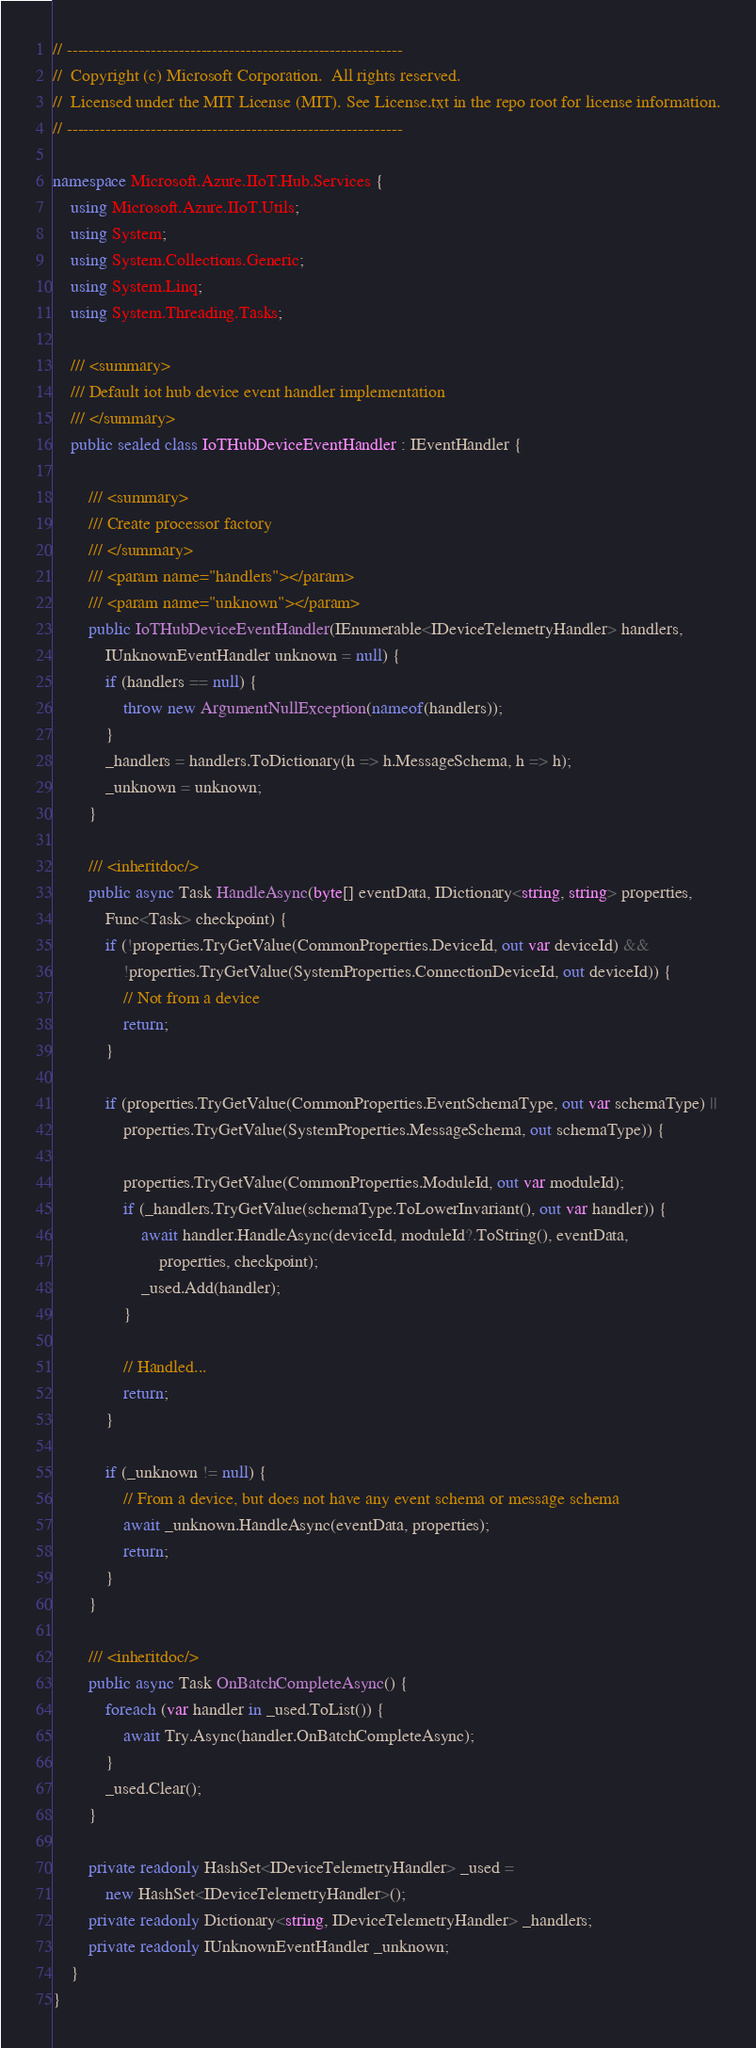<code> <loc_0><loc_0><loc_500><loc_500><_C#_>// ------------------------------------------------------------
//  Copyright (c) Microsoft Corporation.  All rights reserved.
//  Licensed under the MIT License (MIT). See License.txt in the repo root for license information.
// ------------------------------------------------------------

namespace Microsoft.Azure.IIoT.Hub.Services {
    using Microsoft.Azure.IIoT.Utils;
    using System;
    using System.Collections.Generic;
    using System.Linq;
    using System.Threading.Tasks;

    /// <summary>
    /// Default iot hub device event handler implementation
    /// </summary>
    public sealed class IoTHubDeviceEventHandler : IEventHandler {

        /// <summary>
        /// Create processor factory
        /// </summary>
        /// <param name="handlers"></param>
        /// <param name="unknown"></param>
        public IoTHubDeviceEventHandler(IEnumerable<IDeviceTelemetryHandler> handlers,
            IUnknownEventHandler unknown = null) {
            if (handlers == null) {
                throw new ArgumentNullException(nameof(handlers));
            }
            _handlers = handlers.ToDictionary(h => h.MessageSchema, h => h);
            _unknown = unknown;
        }

        /// <inheritdoc/>
        public async Task HandleAsync(byte[] eventData, IDictionary<string, string> properties,
            Func<Task> checkpoint) {
            if (!properties.TryGetValue(CommonProperties.DeviceId, out var deviceId) &&
                !properties.TryGetValue(SystemProperties.ConnectionDeviceId, out deviceId)) {
                // Not from a device
                return;
            }

            if (properties.TryGetValue(CommonProperties.EventSchemaType, out var schemaType) ||
                properties.TryGetValue(SystemProperties.MessageSchema, out schemaType)) {

                properties.TryGetValue(CommonProperties.ModuleId, out var moduleId);
                if (_handlers.TryGetValue(schemaType.ToLowerInvariant(), out var handler)) {
                    await handler.HandleAsync(deviceId, moduleId?.ToString(), eventData,
                        properties, checkpoint);
                    _used.Add(handler);
                }

                // Handled...
                return;
            }

            if (_unknown != null) {
                // From a device, but does not have any event schema or message schema
                await _unknown.HandleAsync(eventData, properties);
                return;
            }
        }

        /// <inheritdoc/>
        public async Task OnBatchCompleteAsync() {
            foreach (var handler in _used.ToList()) {
                await Try.Async(handler.OnBatchCompleteAsync);
            }
            _used.Clear();
        }

        private readonly HashSet<IDeviceTelemetryHandler> _used =
            new HashSet<IDeviceTelemetryHandler>();
        private readonly Dictionary<string, IDeviceTelemetryHandler> _handlers;
        private readonly IUnknownEventHandler _unknown;
    }
}
</code> 